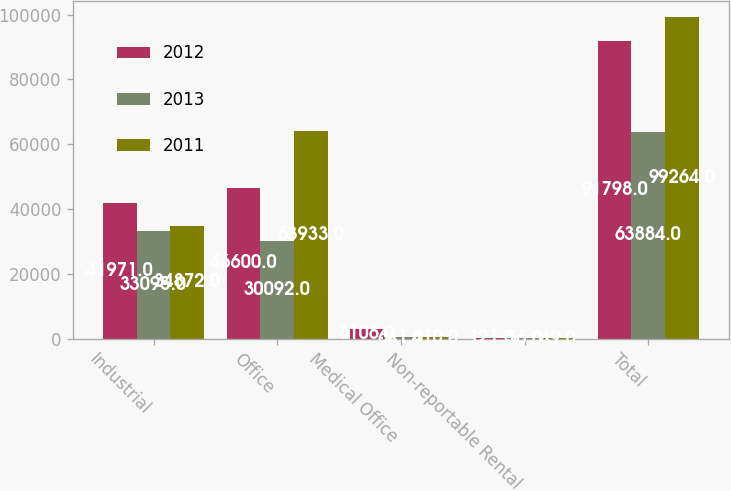Convert chart. <chart><loc_0><loc_0><loc_500><loc_500><stacked_bar_chart><ecel><fcel>Industrial<fcel>Office<fcel>Medical Office<fcel>Non-reportable Rental<fcel>Total<nl><fcel>2012<fcel>41971<fcel>46600<fcel>3106<fcel>121<fcel>91798<nl><fcel>2013<fcel>33095<fcel>30092<fcel>641<fcel>56<fcel>63884<nl><fcel>2011<fcel>34872<fcel>63933<fcel>410<fcel>49<fcel>99264<nl></chart> 